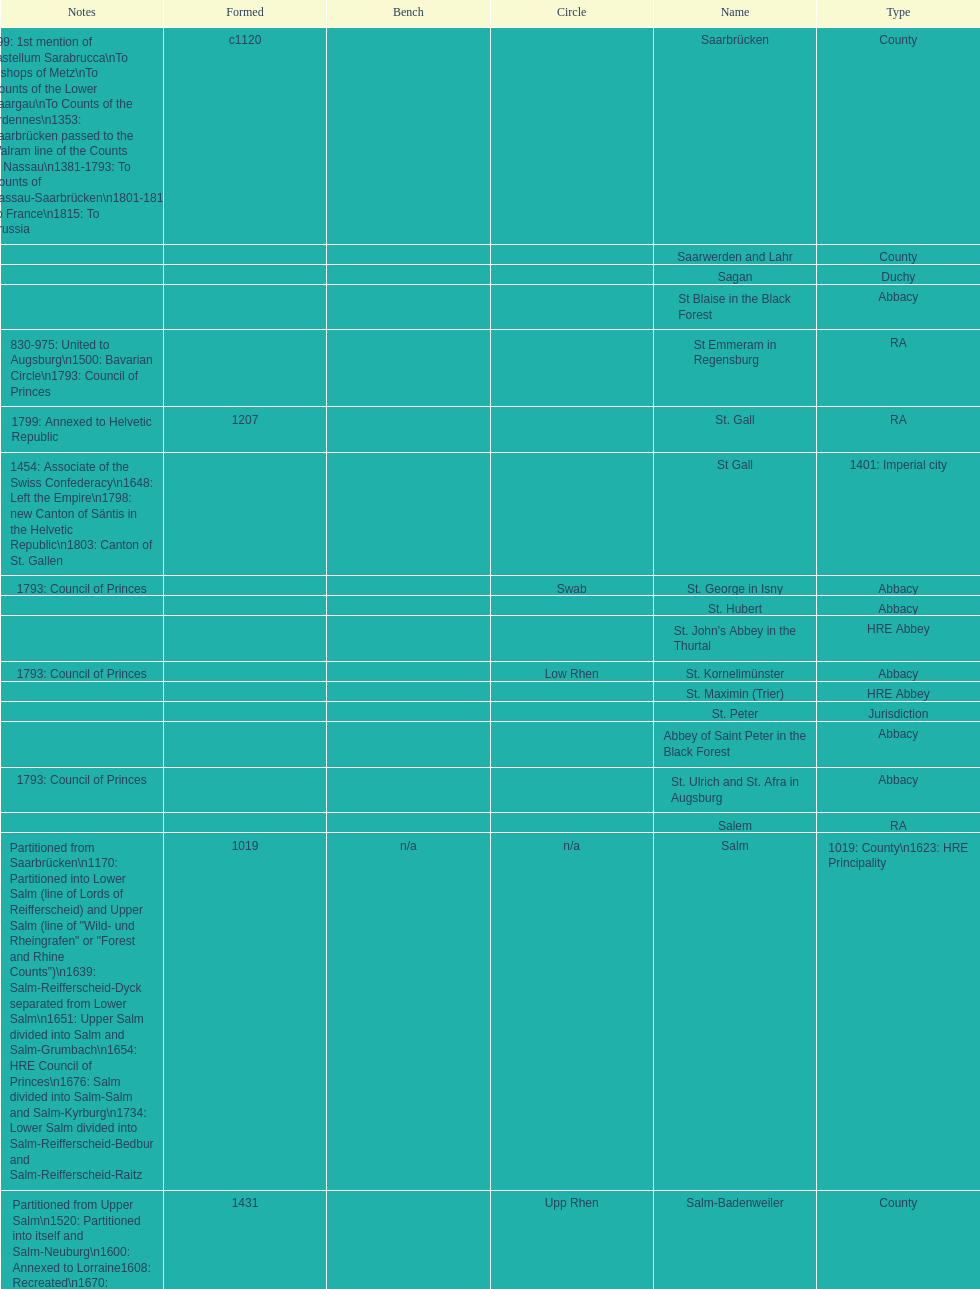What is the state above "sagan"? Saarwerden and Lahr. 